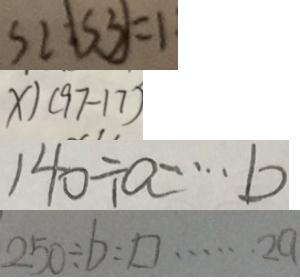Convert formula to latex. <formula><loc_0><loc_0><loc_500><loc_500>S 2 : \boxed { S 3 } = 1 
 x \vert ( 9 7 - 1 7 ) 
 1 4 0 \div a \cdots b 
 2 5 0 \div b = \square \cdots 2 a</formula> 